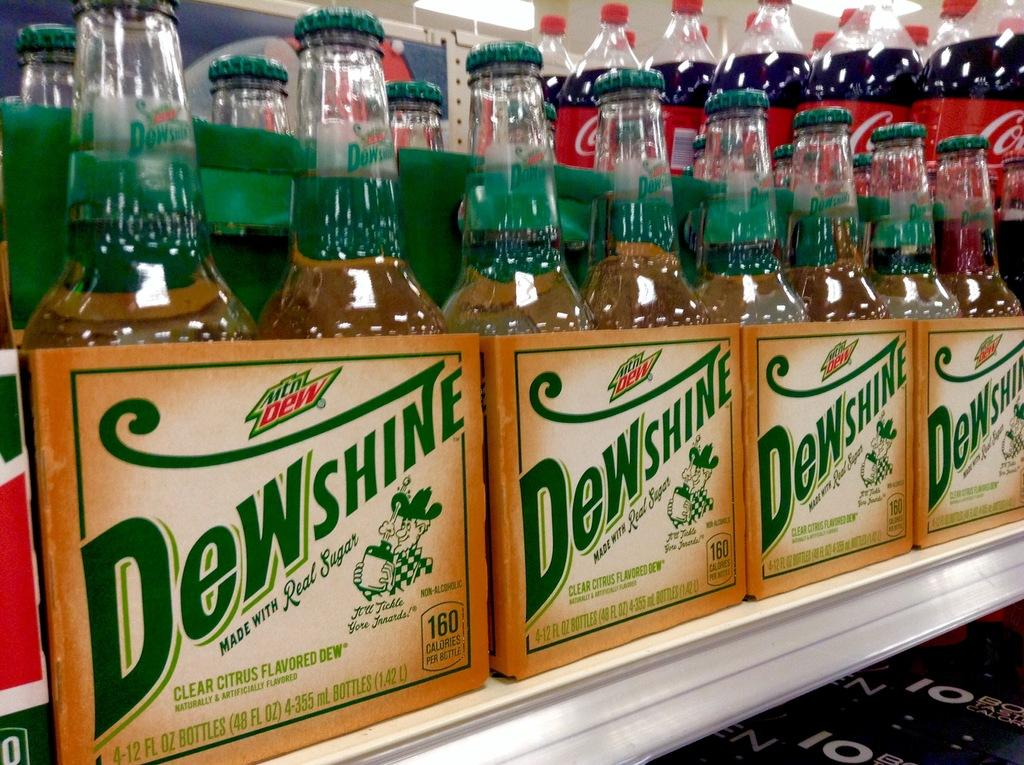<image>
Present a compact description of the photo's key features. Four-packs of Dewshine bottles in rows on a shelf. 